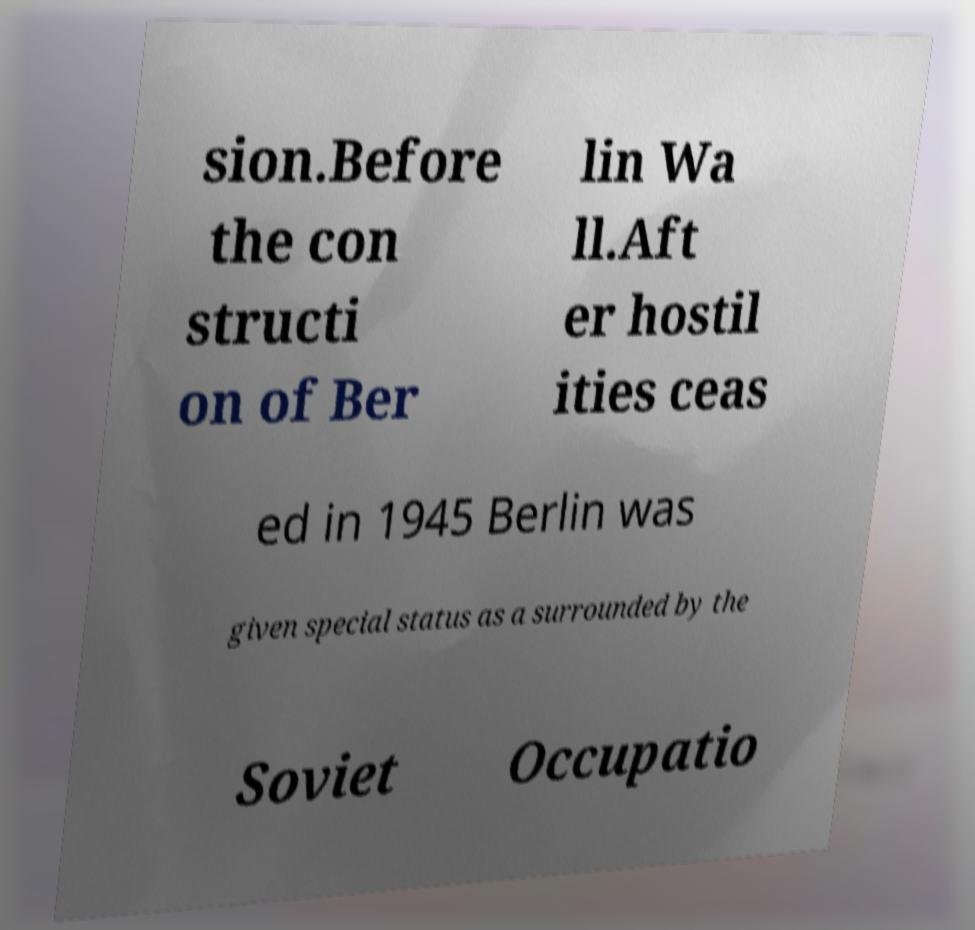Could you assist in decoding the text presented in this image and type it out clearly? sion.Before the con structi on of Ber lin Wa ll.Aft er hostil ities ceas ed in 1945 Berlin was given special status as a surrounded by the Soviet Occupatio 